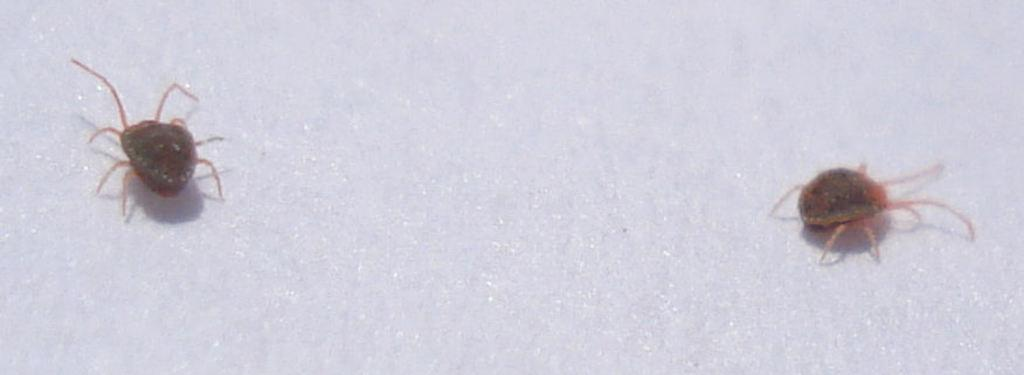How many insects are present in the image? There are two insects in the image. What type of icicle can be seen hanging from the silver record in the image? There is no icicle or silver record present in the image; it features two insects. 